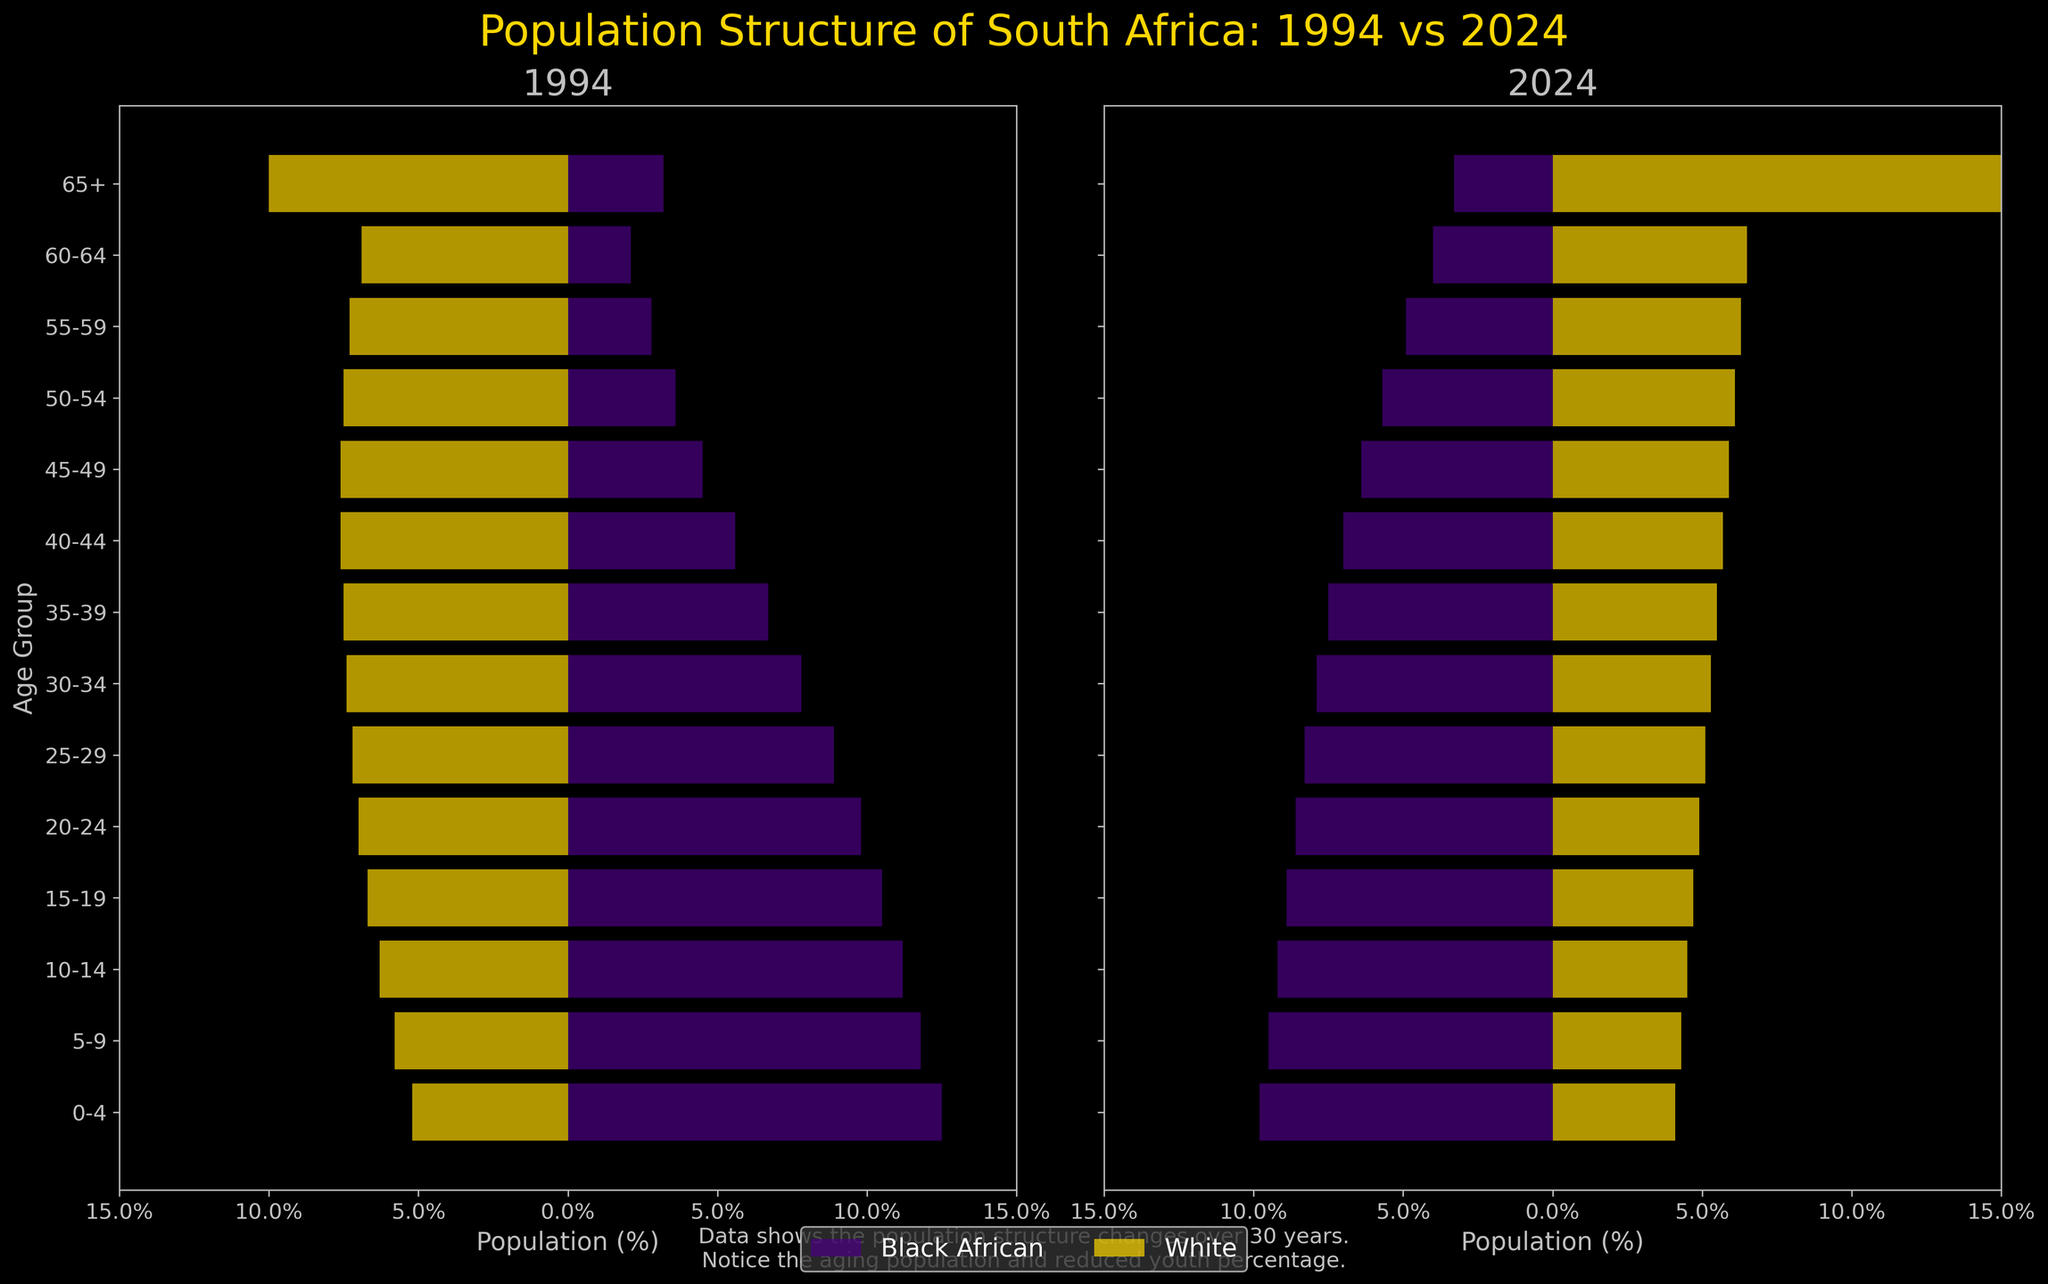How does the percentage of Black African population aged 0-4 change from 1994 to 2024? Comparing the percentages of the Black African population in the 0-4 age group, it is 12.5% in 1994 and 9.8% in 2024.
Answer: It decreases from 12.5% to 9.8% Which group shows the most significant increase in the 65+ age group from 1994 to 2024? Comparing the percentages in the 65+ age group across all ethnicities, Black African increases from 3.2% to 3.3%, White increases from 10.0% to 31.1%, Coloured increases from 13.0% to 22.0%, and Indian/Asian increases from 26.9% to 38.9%. The Indian/Asian group shows the largest increase.
Answer: Indian/Asian What is the difference in the percentage of the White population aged 30-34 between 1994 and 2024? The percentage of the White population aged 30-34 in 1994 is 7.4%, and in 2024 it is 5.3%. The difference is 7.4% - 5.3% = 2.1%.
Answer: 2.1% In 1994, which age group has the highest percentage of Black Africans? Looking at the 1994 data, the age group 0-4 has the highest percentage of Black Africans at 12.5%.
Answer: 0-4 How does the overall trend in the population structure from 1994 to 2024 appear for Black Africans? For Black Africans, the percentage in younger age groups (0-19) decreases, while the percentage in older age groups (20-65+) generally increases. This indicates an aging population.
Answer: Aging population What is the percentage of the Coloured population aged 45-49 in 1994 and 2024, and what is the percentage increase? In 1994, the percentage is 5.2%, and in 2024 it is 5.4%. The percentage increase is calculated as (5.4% - 5.2%) / 5.2% * 100 = 3.85%.
Answer: 3.85% Which ethnic group has the smallest percentage of the 50-54 age group in 2024? Comparing all ethnic groups in the 50-54 age group for 2024: Black African (5.7%), White (6.1%), Coloured (5.2%), and Indian/Asian (3.9%). The Indian/Asian group has the smallest percentage at 3.9%.
Answer: Indian/Asian How does the youth population trend (ages 0-19) change for Black Africans from 1994 to 2024? Summing the 0-19 age groups for Black Africans in 1994 (12.5 + 11.8 + 11.2 + 10.5 = 46%) and in 2024 (9.8 + 9.5 + 9.2 + 8.9 = 37.4%), there's a decrease from 46% to 37.4%.
Answer: Decreases from 46% to 37.4% In 2024, which age group has the highest percentage of the Indian/Asian population? In 2024, the Indian/Asian population in the 65+ age group has the highest percentage at 38.9%.
Answer: 65+ 